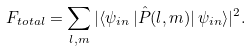<formula> <loc_0><loc_0><loc_500><loc_500>F _ { t o t a l } = \sum _ { l , m } | \langle \psi _ { i n } \, | \hat { P } ( l , m ) | \, \psi _ { i n } \rangle | ^ { 2 } .</formula> 